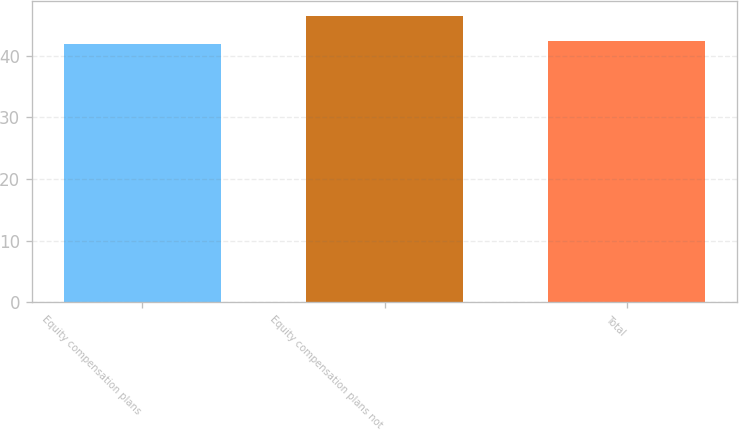<chart> <loc_0><loc_0><loc_500><loc_500><bar_chart><fcel>Equity compensation plans<fcel>Equity compensation plans not<fcel>Total<nl><fcel>41.83<fcel>46.44<fcel>42.29<nl></chart> 